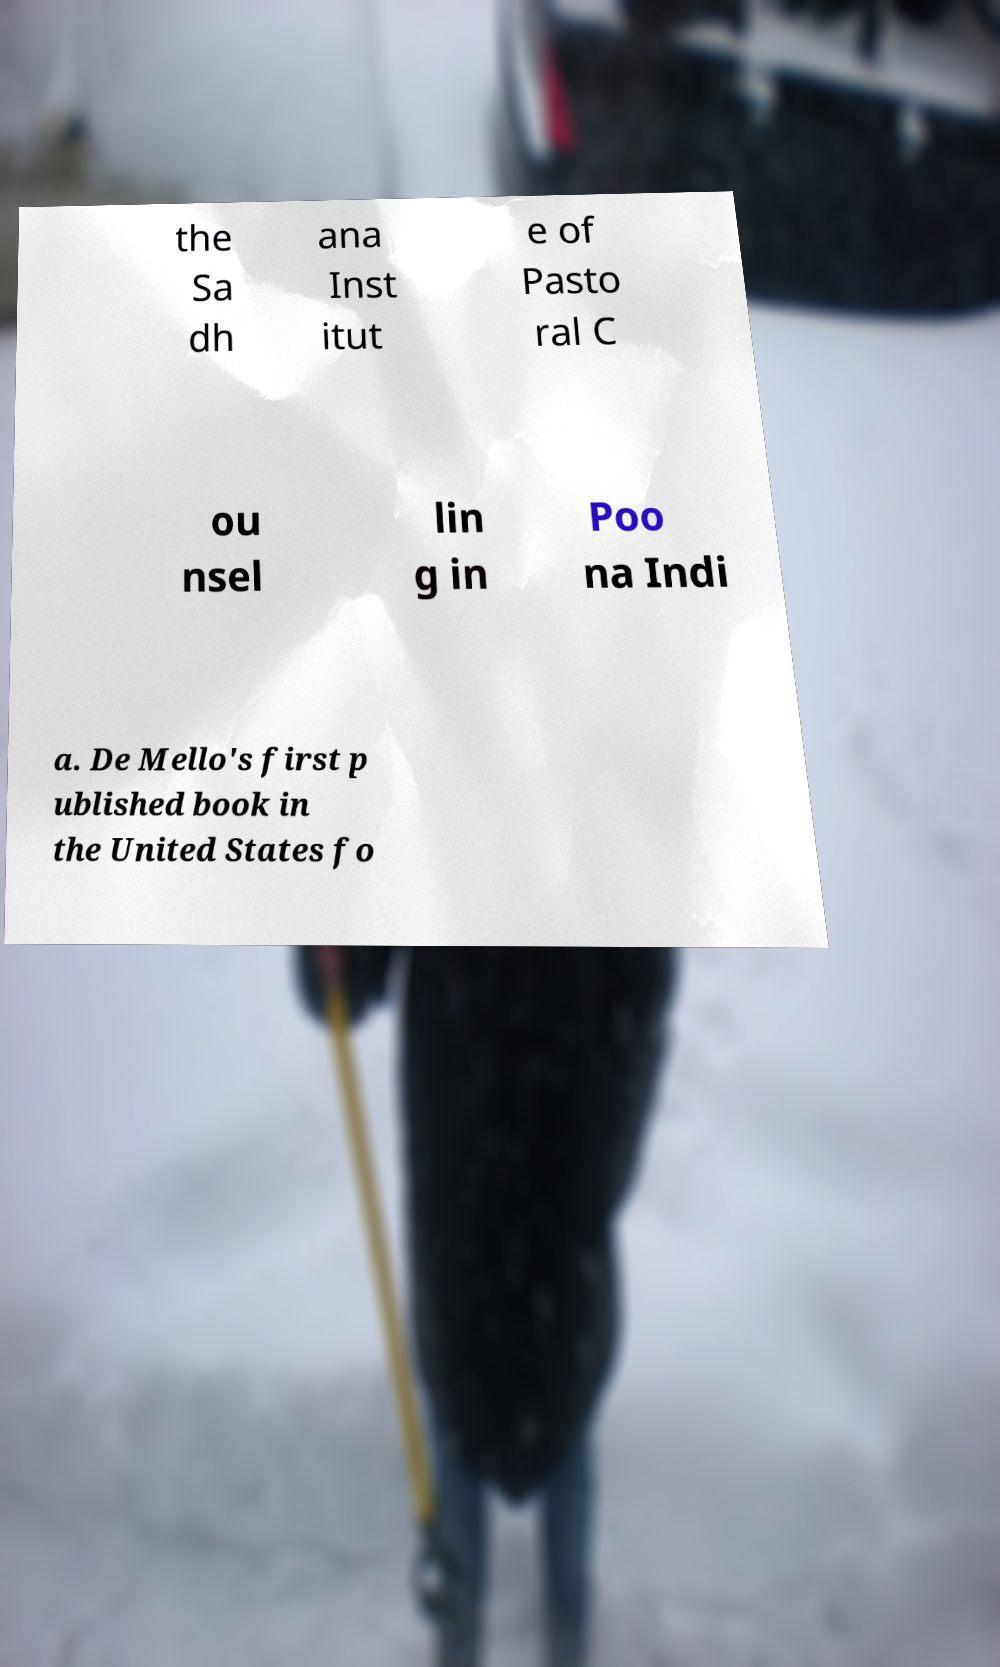I need the written content from this picture converted into text. Can you do that? the Sa dh ana Inst itut e of Pasto ral C ou nsel lin g in Poo na Indi a. De Mello's first p ublished book in the United States fo 